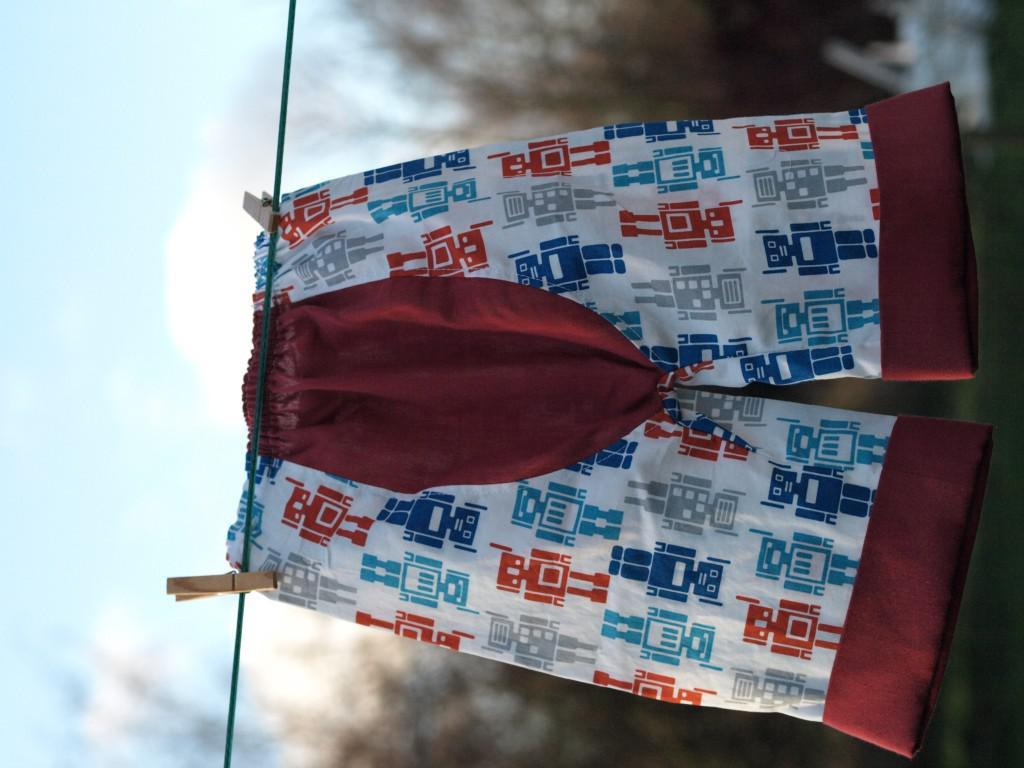In which direction is the image oriented? The image is in the left direction. What can be seen hanging in the image? There is a short hanging on a rope in the image. What type of natural environment is visible in the background of the image? There are many trees in the background of the image. What part of the sky is visible in the image? The sky is visible on the left side of the image. What type of van can be seen parked near the hanging in the image? There is no van present in the image; it only features a short hanging on a rope and a natural environment. What advice is given by the trees in the background of the image? The trees in the background of the image do not give any advice, as they are inanimate objects. 